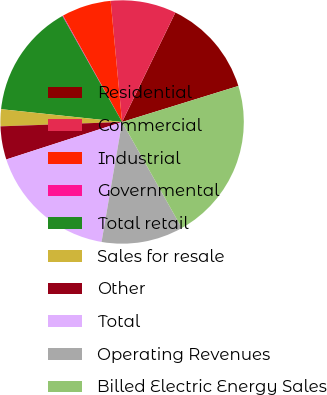<chart> <loc_0><loc_0><loc_500><loc_500><pie_chart><fcel>Residential<fcel>Commercial<fcel>Industrial<fcel>Governmental<fcel>Total retail<fcel>Sales for resale<fcel>Other<fcel>Total<fcel>Operating Revenues<fcel>Billed Electric Energy Sales<nl><fcel>13.01%<fcel>8.71%<fcel>6.56%<fcel>0.1%<fcel>15.16%<fcel>2.25%<fcel>4.41%<fcel>17.32%<fcel>10.86%<fcel>21.62%<nl></chart> 